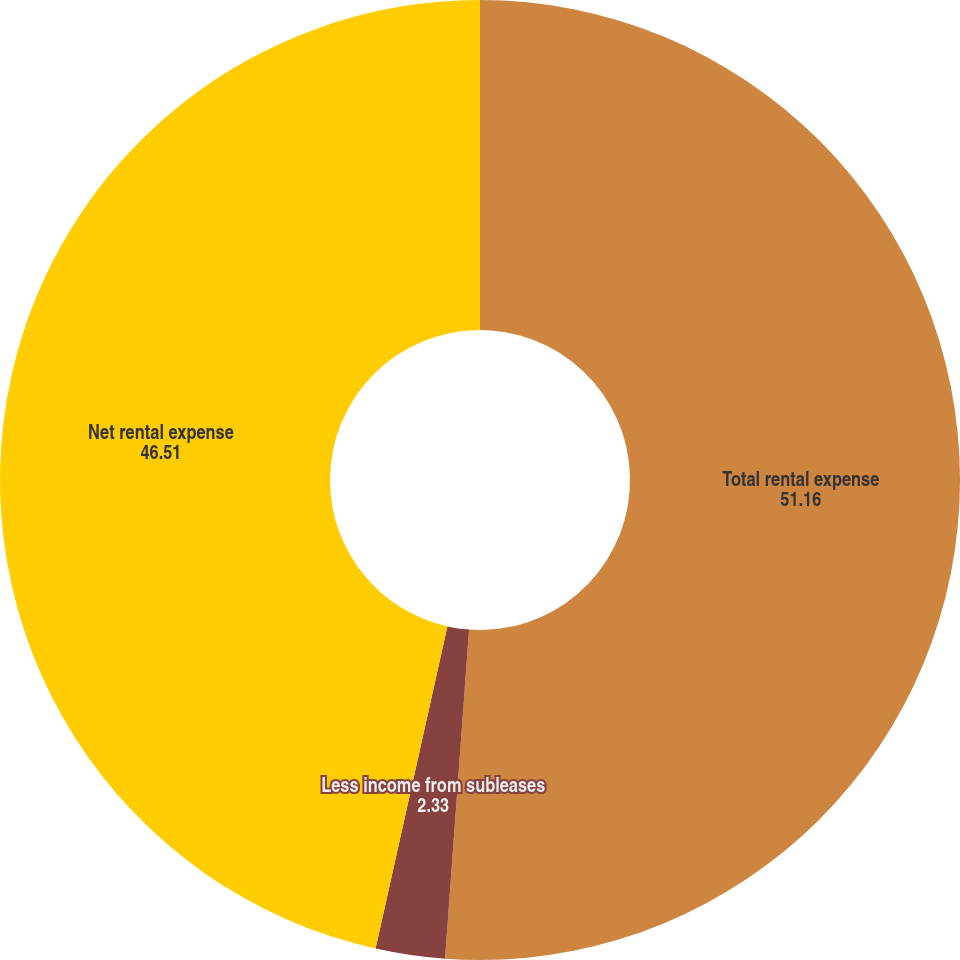Convert chart. <chart><loc_0><loc_0><loc_500><loc_500><pie_chart><fcel>Total rental expense<fcel>Less income from subleases<fcel>Net rental expense<nl><fcel>51.16%<fcel>2.33%<fcel>46.51%<nl></chart> 